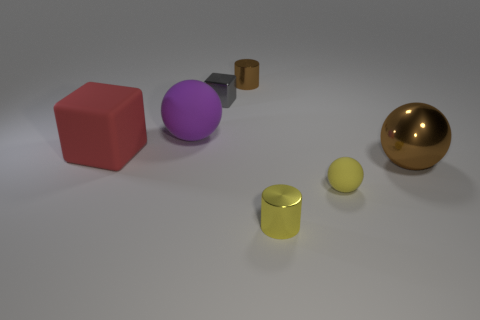What can you tell me about the seemingly reflective surfaces and the lighting in this scene? The scene is eloquently illuminated, casting diffuse shadows and allowing the objects' reflective surfaces to subtly mirror their environment. The golden sphere and the purple sphere in particular display reflective qualities indicative of a smooth, perhaps metallic surface. These reflections contribute to the realism of the scene, suggesting a soft, possibly overhead light source that generates gentle highlights and accentuates the curvature of the spheres and the cylindrical objects. 